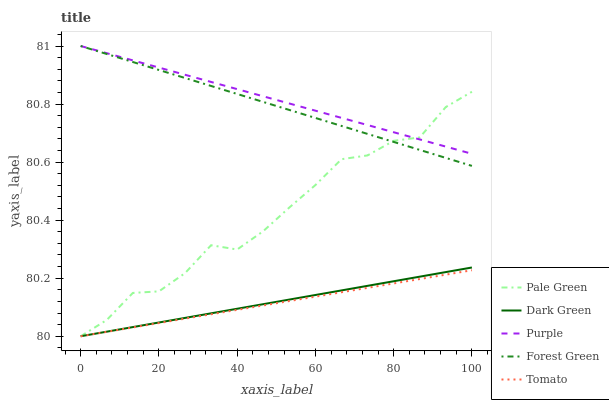Does Tomato have the minimum area under the curve?
Answer yes or no. Yes. Does Purple have the maximum area under the curve?
Answer yes or no. Yes. Does Forest Green have the minimum area under the curve?
Answer yes or no. No. Does Forest Green have the maximum area under the curve?
Answer yes or no. No. Is Dark Green the smoothest?
Answer yes or no. Yes. Is Pale Green the roughest?
Answer yes or no. Yes. Is Tomato the smoothest?
Answer yes or no. No. Is Tomato the roughest?
Answer yes or no. No. Does Tomato have the lowest value?
Answer yes or no. Yes. Does Forest Green have the lowest value?
Answer yes or no. No. Does Forest Green have the highest value?
Answer yes or no. Yes. Does Tomato have the highest value?
Answer yes or no. No. Is Tomato less than Forest Green?
Answer yes or no. Yes. Is Forest Green greater than Tomato?
Answer yes or no. Yes. Does Dark Green intersect Tomato?
Answer yes or no. Yes. Is Dark Green less than Tomato?
Answer yes or no. No. Is Dark Green greater than Tomato?
Answer yes or no. No. Does Tomato intersect Forest Green?
Answer yes or no. No. 